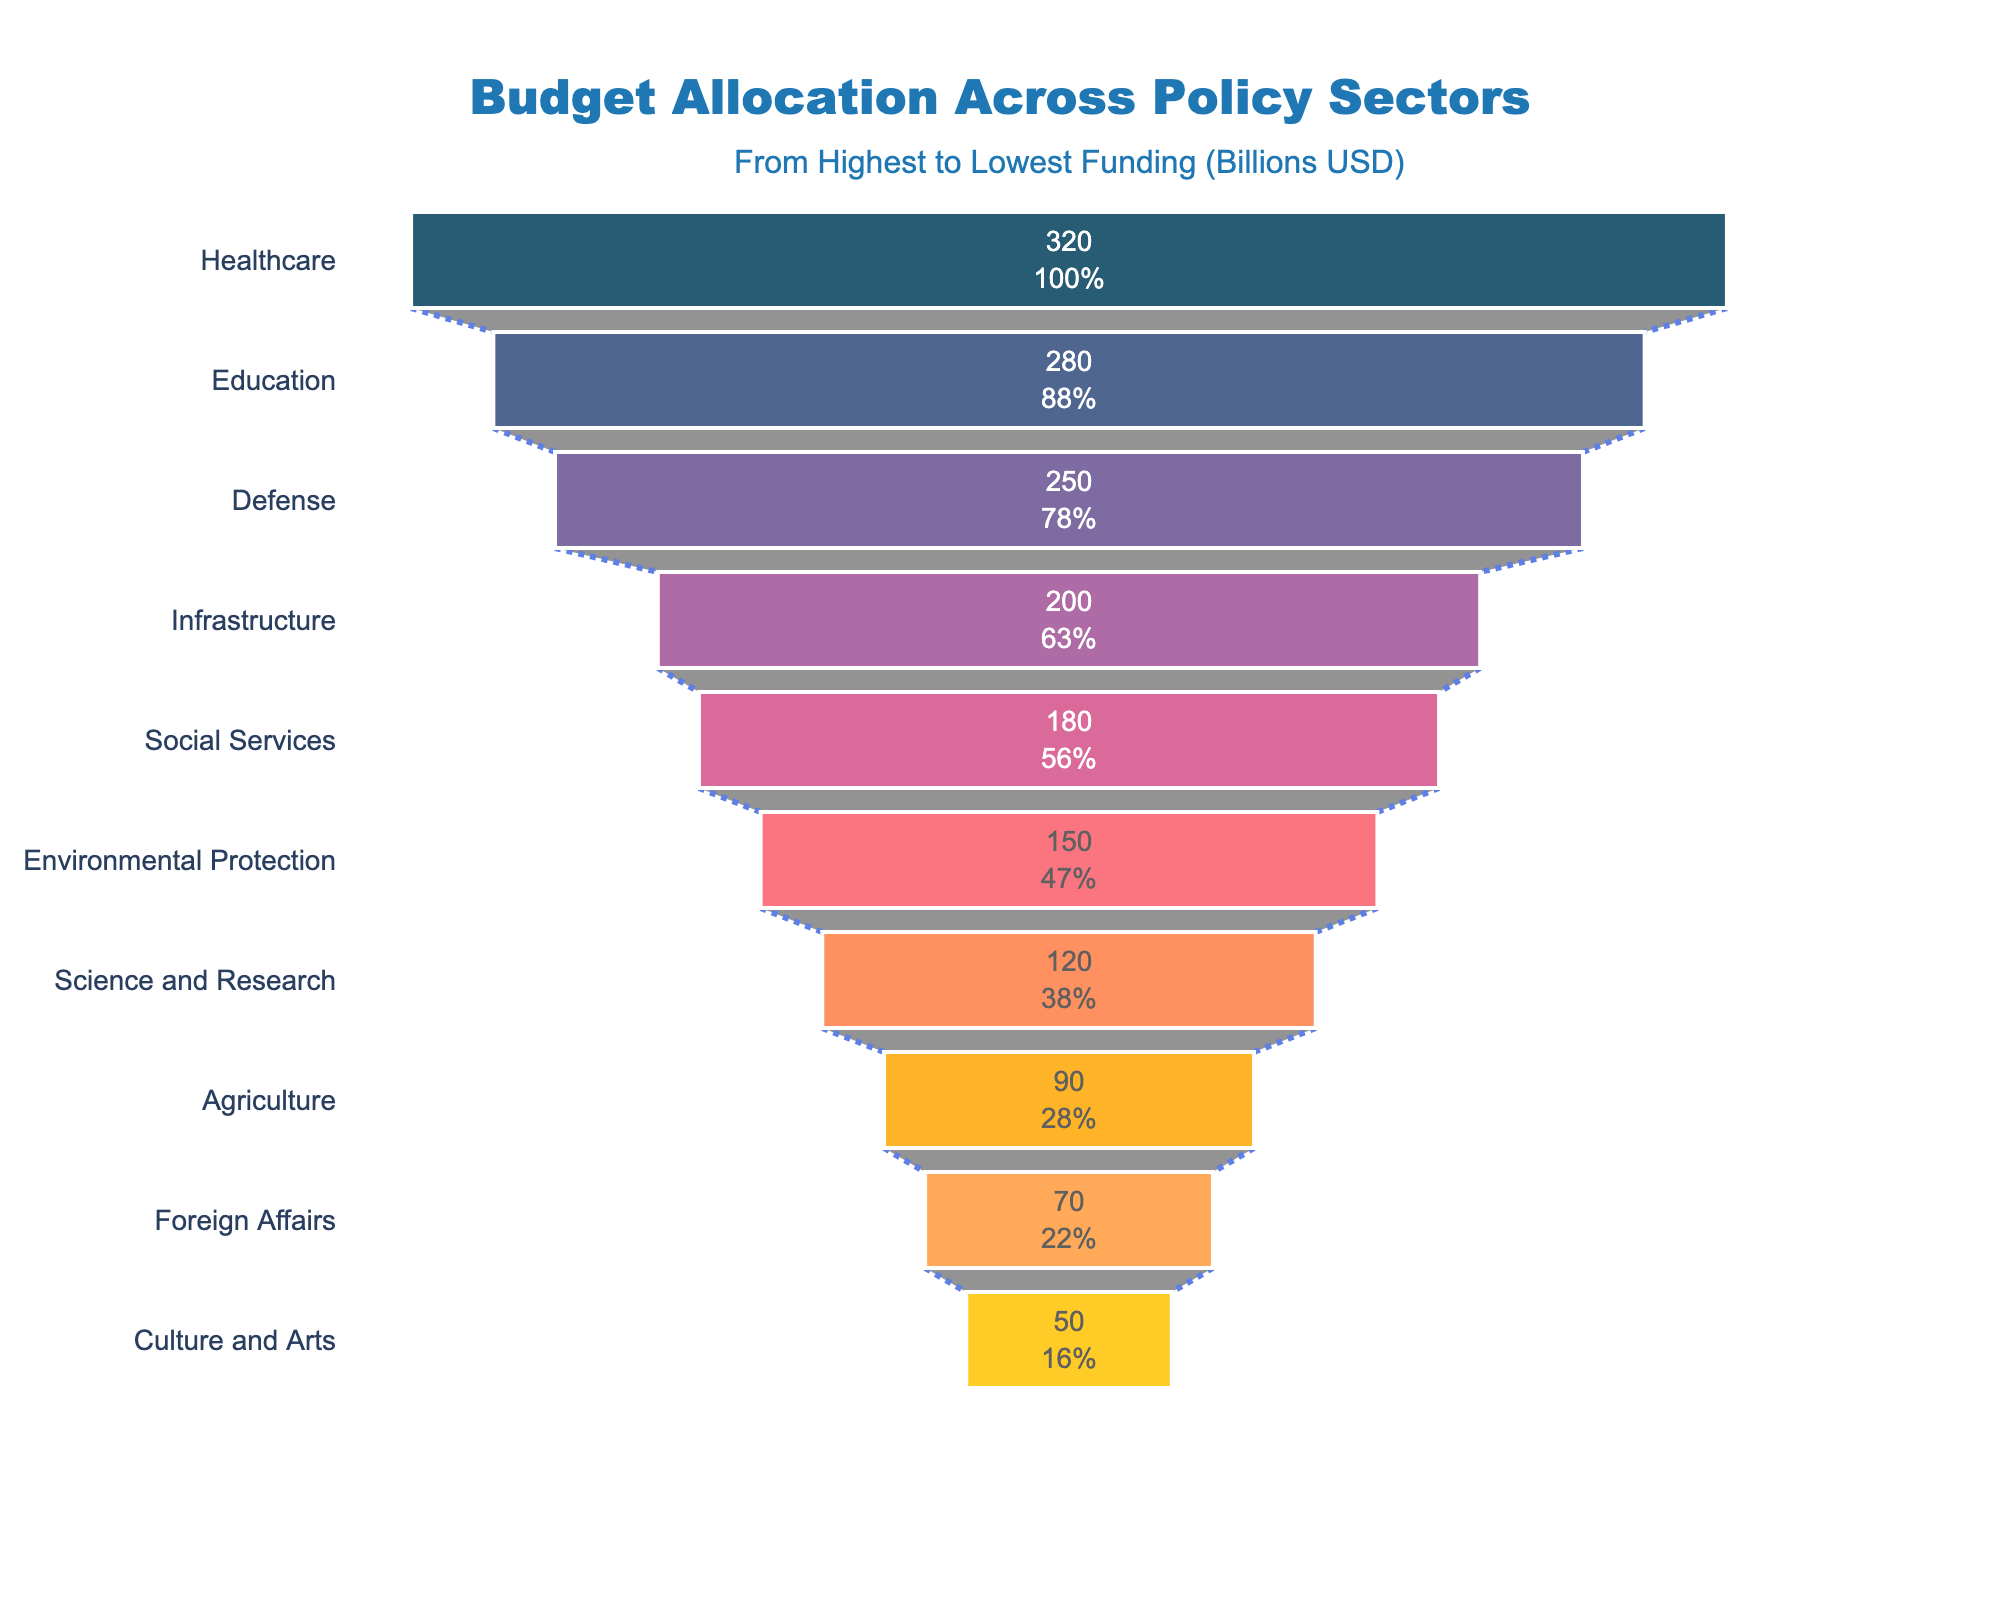what is the title of the chart? The title is located at the top center of the chart, typically in a larger and bolder font to distinguish it.
Answer: Budget Allocation Across Policy Sectors Which policy sector receives the highest budget allocation? The y-axis lists the policy sectors in descending order of their budget allocation. The first sector listed is the one with the highest funding.
Answer: Healthcare What percent of the initial allocation is given to the Education sector? In a Funnel Chart, each segment shows a value with an accompanying percentage, which is the share of that segment relative to the initial (total) allocation. The label inside the Education segment gives this information.
Answer: 21.9% What's the difference in budget allocation between Defense and Infrastructure? By reading the x-axis values corresponding to the Defense and Infrastructure sectors, you can subtract the value of Infrastructure from the value of Defense to find the difference.
Answer: 50 billion USD Which sector has the lowest funding, and what is its allocation? The final segment of the funnel chart represents the sector with the lowest funding, located at the narrowest part of the funnel.
Answer: Culture and Arts, 50 billion USD What is the median budget allocation? To find the median, list all budget allocations in ascending or descending order and locate the middle value.
Answer: 185 billion USD (Infrastructure) How does the budget allocation for Social Services compare to that for Science and Research? Compare the x-axis values for Social Services and Science and Research to determine which one is higher and by how much.
Answer: Social Services has 60 billion USD more than Science and Research Is the sum of allocations for Agriculture and Foreign Affairs higher than that of Environmental Protection? Add the allocations for Agriculture and Foreign Affairs, then compare this sum with the allocation for Environmental Protection.
Answer: No, 160 billion USD is greater than 90 + 70 billion USD How much more funding does Healthcare receive compared to Environmental Protection? Subtract the budget allocation for Environmental Protection from the allocation for Healthcare to determine the difference.
Answer: 170 billion USD What percentage of the total budget is allocated to Infrastructure? Total the initial allocation across all sectors and then calculate the percentage that Infrastructure represents from that total.
Answer: 12.2% 